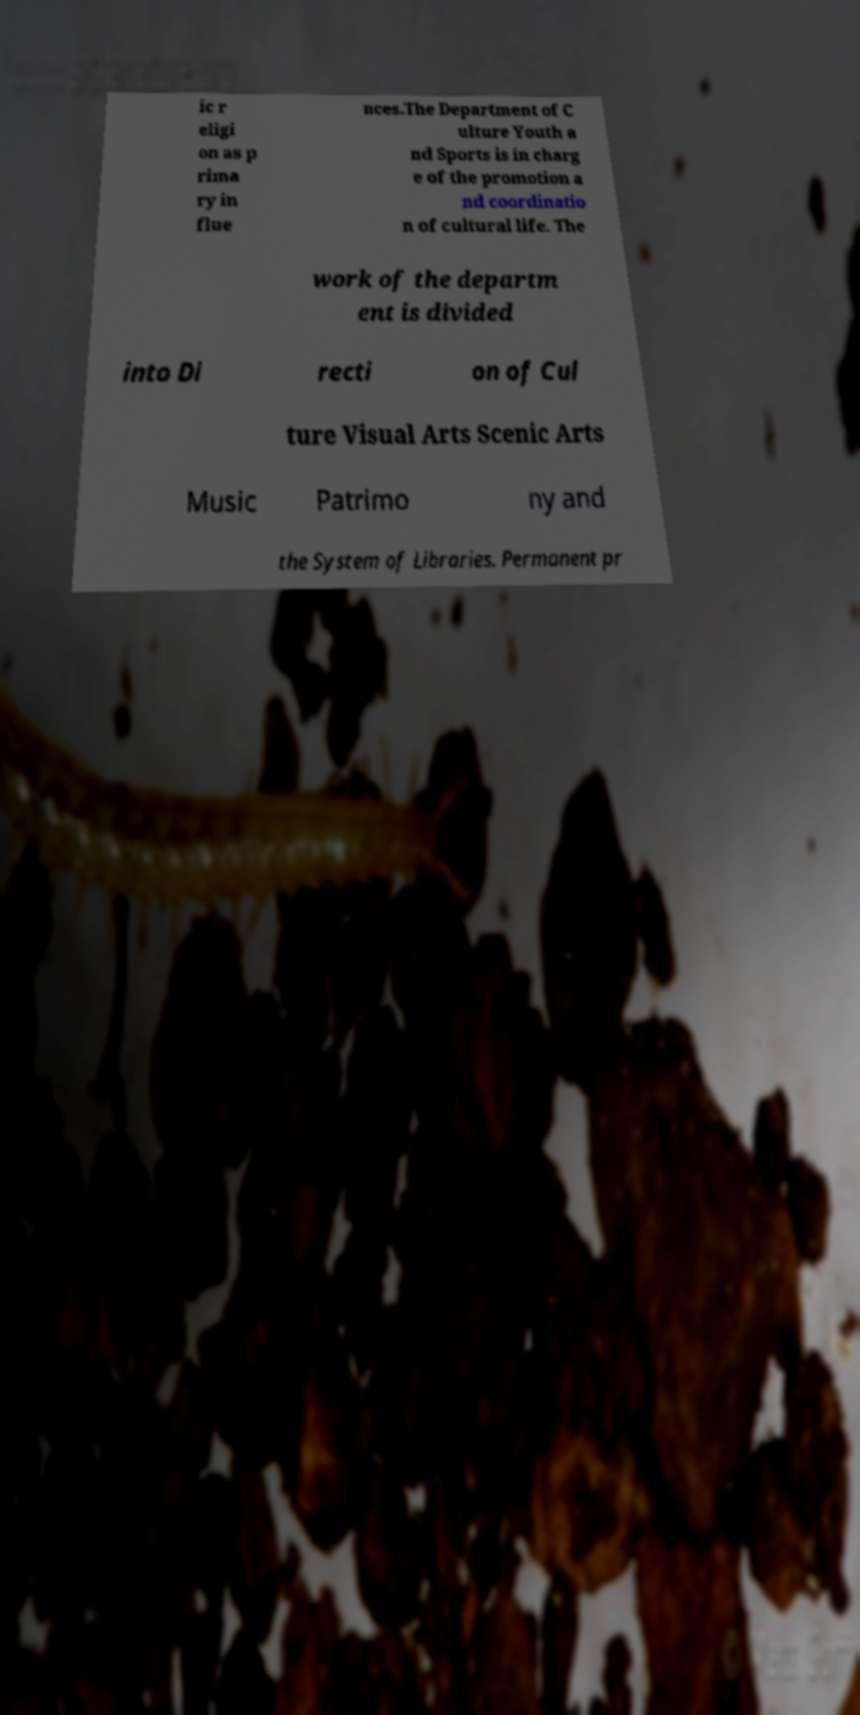Could you assist in decoding the text presented in this image and type it out clearly? ic r eligi on as p rima ry in flue nces.The Department of C ulture Youth a nd Sports is in charg e of the promotion a nd coordinatio n of cultural life. The work of the departm ent is divided into Di recti on of Cul ture Visual Arts Scenic Arts Music Patrimo ny and the System of Libraries. Permanent pr 